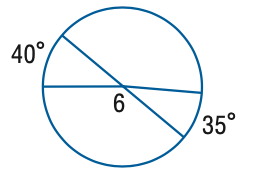Answer the mathemtical geometry problem and directly provide the correct option letter.
Question: Find the measure of \angle 6.
Choices: A: 130 B: 140 C: 142.5 D: 145 B 